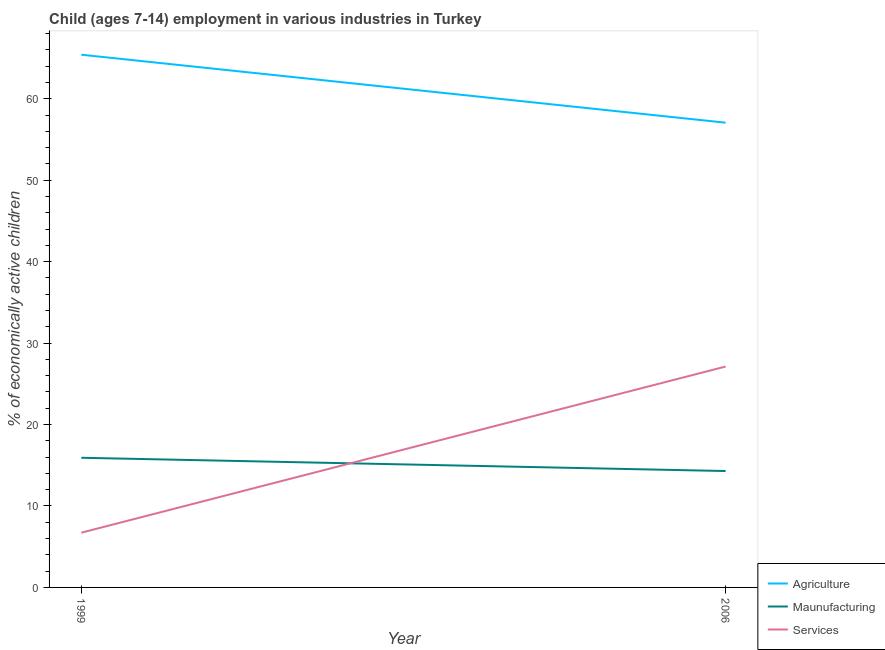How many different coloured lines are there?
Your response must be concise. 3. Does the line corresponding to percentage of economically active children in services intersect with the line corresponding to percentage of economically active children in manufacturing?
Give a very brief answer. Yes. Is the number of lines equal to the number of legend labels?
Provide a short and direct response. Yes. What is the percentage of economically active children in manufacturing in 2006?
Keep it short and to the point. 14.29. Across all years, what is the maximum percentage of economically active children in services?
Make the answer very short. 27.12. Across all years, what is the minimum percentage of economically active children in agriculture?
Offer a terse response. 57.06. In which year was the percentage of economically active children in manufacturing maximum?
Your response must be concise. 1999. What is the total percentage of economically active children in agriculture in the graph?
Offer a very short reply. 122.47. What is the difference between the percentage of economically active children in agriculture in 1999 and that in 2006?
Provide a succinct answer. 8.35. What is the difference between the percentage of economically active children in services in 1999 and the percentage of economically active children in manufacturing in 2006?
Make the answer very short. -7.57. What is the average percentage of economically active children in manufacturing per year?
Your answer should be very brief. 15.1. In the year 2006, what is the difference between the percentage of economically active children in manufacturing and percentage of economically active children in agriculture?
Your response must be concise. -42.77. In how many years, is the percentage of economically active children in agriculture greater than 40 %?
Give a very brief answer. 2. What is the ratio of the percentage of economically active children in agriculture in 1999 to that in 2006?
Provide a succinct answer. 1.15. Is the percentage of economically active children in services in 1999 less than that in 2006?
Provide a short and direct response. Yes. In how many years, is the percentage of economically active children in manufacturing greater than the average percentage of economically active children in manufacturing taken over all years?
Provide a short and direct response. 1. Does the percentage of economically active children in manufacturing monotonically increase over the years?
Your answer should be compact. No. What is the difference between two consecutive major ticks on the Y-axis?
Your response must be concise. 10. Does the graph contain any zero values?
Your answer should be very brief. No. Where does the legend appear in the graph?
Your answer should be very brief. Bottom right. What is the title of the graph?
Ensure brevity in your answer.  Child (ages 7-14) employment in various industries in Turkey. Does "Fuel" appear as one of the legend labels in the graph?
Provide a short and direct response. No. What is the label or title of the X-axis?
Your response must be concise. Year. What is the label or title of the Y-axis?
Provide a short and direct response. % of economically active children. What is the % of economically active children of Agriculture in 1999?
Provide a short and direct response. 65.41. What is the % of economically active children in Maunufacturing in 1999?
Your answer should be very brief. 15.92. What is the % of economically active children of Services in 1999?
Provide a short and direct response. 6.72. What is the % of economically active children of Agriculture in 2006?
Provide a short and direct response. 57.06. What is the % of economically active children of Maunufacturing in 2006?
Keep it short and to the point. 14.29. What is the % of economically active children of Services in 2006?
Provide a short and direct response. 27.12. Across all years, what is the maximum % of economically active children in Agriculture?
Your answer should be compact. 65.41. Across all years, what is the maximum % of economically active children of Maunufacturing?
Provide a succinct answer. 15.92. Across all years, what is the maximum % of economically active children of Services?
Make the answer very short. 27.12. Across all years, what is the minimum % of economically active children of Agriculture?
Give a very brief answer. 57.06. Across all years, what is the minimum % of economically active children in Maunufacturing?
Provide a short and direct response. 14.29. Across all years, what is the minimum % of economically active children in Services?
Your answer should be compact. 6.72. What is the total % of economically active children of Agriculture in the graph?
Your response must be concise. 122.47. What is the total % of economically active children of Maunufacturing in the graph?
Provide a succinct answer. 30.21. What is the total % of economically active children in Services in the graph?
Ensure brevity in your answer.  33.84. What is the difference between the % of economically active children in Agriculture in 1999 and that in 2006?
Provide a short and direct response. 8.35. What is the difference between the % of economically active children in Maunufacturing in 1999 and that in 2006?
Keep it short and to the point. 1.63. What is the difference between the % of economically active children in Services in 1999 and that in 2006?
Keep it short and to the point. -20.4. What is the difference between the % of economically active children in Agriculture in 1999 and the % of economically active children in Maunufacturing in 2006?
Provide a short and direct response. 51.12. What is the difference between the % of economically active children in Agriculture in 1999 and the % of economically active children in Services in 2006?
Your answer should be very brief. 38.29. What is the difference between the % of economically active children in Maunufacturing in 1999 and the % of economically active children in Services in 2006?
Your answer should be very brief. -11.2. What is the average % of economically active children of Agriculture per year?
Keep it short and to the point. 61.23. What is the average % of economically active children of Maunufacturing per year?
Your response must be concise. 15.1. What is the average % of economically active children of Services per year?
Offer a terse response. 16.92. In the year 1999, what is the difference between the % of economically active children in Agriculture and % of economically active children in Maunufacturing?
Make the answer very short. 49.49. In the year 1999, what is the difference between the % of economically active children of Agriculture and % of economically active children of Services?
Provide a short and direct response. 58.68. In the year 1999, what is the difference between the % of economically active children in Maunufacturing and % of economically active children in Services?
Make the answer very short. 9.2. In the year 2006, what is the difference between the % of economically active children of Agriculture and % of economically active children of Maunufacturing?
Offer a terse response. 42.77. In the year 2006, what is the difference between the % of economically active children in Agriculture and % of economically active children in Services?
Offer a terse response. 29.94. In the year 2006, what is the difference between the % of economically active children of Maunufacturing and % of economically active children of Services?
Give a very brief answer. -12.83. What is the ratio of the % of economically active children of Agriculture in 1999 to that in 2006?
Keep it short and to the point. 1.15. What is the ratio of the % of economically active children of Maunufacturing in 1999 to that in 2006?
Your answer should be very brief. 1.11. What is the ratio of the % of economically active children of Services in 1999 to that in 2006?
Give a very brief answer. 0.25. What is the difference between the highest and the second highest % of economically active children in Agriculture?
Offer a very short reply. 8.35. What is the difference between the highest and the second highest % of economically active children of Maunufacturing?
Your answer should be very brief. 1.63. What is the difference between the highest and the second highest % of economically active children in Services?
Your answer should be very brief. 20.4. What is the difference between the highest and the lowest % of economically active children in Agriculture?
Your answer should be very brief. 8.35. What is the difference between the highest and the lowest % of economically active children in Maunufacturing?
Your answer should be compact. 1.63. What is the difference between the highest and the lowest % of economically active children in Services?
Offer a terse response. 20.4. 